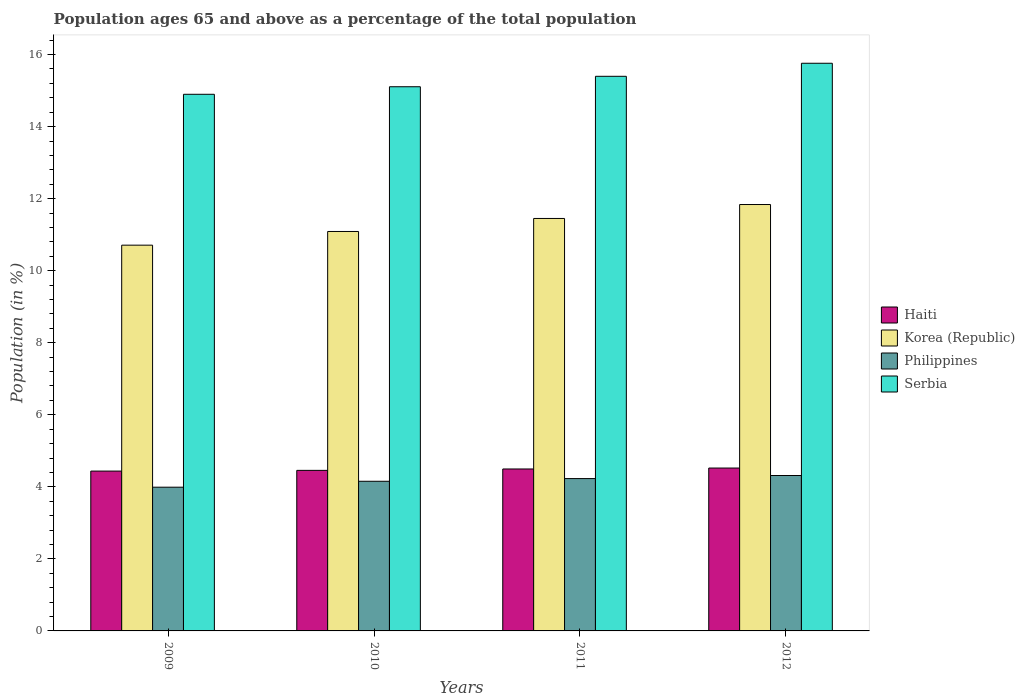How many bars are there on the 1st tick from the left?
Offer a very short reply. 4. How many bars are there on the 4th tick from the right?
Your response must be concise. 4. What is the percentage of the population ages 65 and above in Korea (Republic) in 2011?
Make the answer very short. 11.45. Across all years, what is the maximum percentage of the population ages 65 and above in Korea (Republic)?
Give a very brief answer. 11.84. Across all years, what is the minimum percentage of the population ages 65 and above in Haiti?
Offer a terse response. 4.44. In which year was the percentage of the population ages 65 and above in Philippines minimum?
Your answer should be very brief. 2009. What is the total percentage of the population ages 65 and above in Korea (Republic) in the graph?
Give a very brief answer. 45.08. What is the difference between the percentage of the population ages 65 and above in Korea (Republic) in 2010 and that in 2011?
Offer a terse response. -0.36. What is the difference between the percentage of the population ages 65 and above in Philippines in 2011 and the percentage of the population ages 65 and above in Korea (Republic) in 2010?
Offer a very short reply. -6.86. What is the average percentage of the population ages 65 and above in Korea (Republic) per year?
Your answer should be very brief. 11.27. In the year 2009, what is the difference between the percentage of the population ages 65 and above in Philippines and percentage of the population ages 65 and above in Haiti?
Your answer should be very brief. -0.45. What is the ratio of the percentage of the population ages 65 and above in Korea (Republic) in 2011 to that in 2012?
Offer a very short reply. 0.97. What is the difference between the highest and the second highest percentage of the population ages 65 and above in Philippines?
Provide a short and direct response. 0.09. What is the difference between the highest and the lowest percentage of the population ages 65 and above in Philippines?
Ensure brevity in your answer.  0.32. Is it the case that in every year, the sum of the percentage of the population ages 65 and above in Haiti and percentage of the population ages 65 and above in Korea (Republic) is greater than the sum of percentage of the population ages 65 and above in Serbia and percentage of the population ages 65 and above in Philippines?
Provide a succinct answer. Yes. Is it the case that in every year, the sum of the percentage of the population ages 65 and above in Serbia and percentage of the population ages 65 and above in Haiti is greater than the percentage of the population ages 65 and above in Philippines?
Your answer should be compact. Yes. How many bars are there?
Offer a terse response. 16. Where does the legend appear in the graph?
Ensure brevity in your answer.  Center right. What is the title of the graph?
Offer a very short reply. Population ages 65 and above as a percentage of the total population. What is the Population (in %) in Haiti in 2009?
Make the answer very short. 4.44. What is the Population (in %) of Korea (Republic) in 2009?
Provide a succinct answer. 10.71. What is the Population (in %) of Philippines in 2009?
Give a very brief answer. 3.99. What is the Population (in %) in Serbia in 2009?
Your response must be concise. 14.9. What is the Population (in %) of Haiti in 2010?
Make the answer very short. 4.46. What is the Population (in %) in Korea (Republic) in 2010?
Your response must be concise. 11.09. What is the Population (in %) in Philippines in 2010?
Your answer should be compact. 4.15. What is the Population (in %) of Serbia in 2010?
Offer a terse response. 15.11. What is the Population (in %) in Haiti in 2011?
Make the answer very short. 4.5. What is the Population (in %) of Korea (Republic) in 2011?
Provide a succinct answer. 11.45. What is the Population (in %) of Philippines in 2011?
Provide a short and direct response. 4.23. What is the Population (in %) in Serbia in 2011?
Offer a very short reply. 15.4. What is the Population (in %) in Haiti in 2012?
Make the answer very short. 4.52. What is the Population (in %) in Korea (Republic) in 2012?
Provide a short and direct response. 11.84. What is the Population (in %) of Philippines in 2012?
Offer a terse response. 4.31. What is the Population (in %) of Serbia in 2012?
Your answer should be compact. 15.76. Across all years, what is the maximum Population (in %) in Haiti?
Give a very brief answer. 4.52. Across all years, what is the maximum Population (in %) in Korea (Republic)?
Your response must be concise. 11.84. Across all years, what is the maximum Population (in %) in Philippines?
Keep it short and to the point. 4.31. Across all years, what is the maximum Population (in %) of Serbia?
Keep it short and to the point. 15.76. Across all years, what is the minimum Population (in %) of Haiti?
Your answer should be compact. 4.44. Across all years, what is the minimum Population (in %) in Korea (Republic)?
Make the answer very short. 10.71. Across all years, what is the minimum Population (in %) of Philippines?
Your answer should be very brief. 3.99. Across all years, what is the minimum Population (in %) in Serbia?
Provide a short and direct response. 14.9. What is the total Population (in %) in Haiti in the graph?
Your answer should be compact. 17.91. What is the total Population (in %) in Korea (Republic) in the graph?
Your response must be concise. 45.08. What is the total Population (in %) in Philippines in the graph?
Make the answer very short. 16.69. What is the total Population (in %) of Serbia in the graph?
Your answer should be very brief. 61.16. What is the difference between the Population (in %) in Haiti in 2009 and that in 2010?
Give a very brief answer. -0.02. What is the difference between the Population (in %) of Korea (Republic) in 2009 and that in 2010?
Provide a succinct answer. -0.38. What is the difference between the Population (in %) in Philippines in 2009 and that in 2010?
Offer a very short reply. -0.16. What is the difference between the Population (in %) in Serbia in 2009 and that in 2010?
Your answer should be very brief. -0.21. What is the difference between the Population (in %) in Haiti in 2009 and that in 2011?
Your response must be concise. -0.06. What is the difference between the Population (in %) in Korea (Republic) in 2009 and that in 2011?
Offer a terse response. -0.74. What is the difference between the Population (in %) of Philippines in 2009 and that in 2011?
Offer a very short reply. -0.24. What is the difference between the Population (in %) in Serbia in 2009 and that in 2011?
Provide a short and direct response. -0.5. What is the difference between the Population (in %) in Haiti in 2009 and that in 2012?
Offer a very short reply. -0.08. What is the difference between the Population (in %) in Korea (Republic) in 2009 and that in 2012?
Your response must be concise. -1.13. What is the difference between the Population (in %) in Philippines in 2009 and that in 2012?
Provide a short and direct response. -0.32. What is the difference between the Population (in %) in Serbia in 2009 and that in 2012?
Your response must be concise. -0.86. What is the difference between the Population (in %) in Haiti in 2010 and that in 2011?
Ensure brevity in your answer.  -0.04. What is the difference between the Population (in %) in Korea (Republic) in 2010 and that in 2011?
Provide a succinct answer. -0.36. What is the difference between the Population (in %) of Philippines in 2010 and that in 2011?
Ensure brevity in your answer.  -0.07. What is the difference between the Population (in %) of Serbia in 2010 and that in 2011?
Give a very brief answer. -0.29. What is the difference between the Population (in %) in Haiti in 2010 and that in 2012?
Your response must be concise. -0.06. What is the difference between the Population (in %) in Korea (Republic) in 2010 and that in 2012?
Your answer should be very brief. -0.75. What is the difference between the Population (in %) in Philippines in 2010 and that in 2012?
Provide a succinct answer. -0.16. What is the difference between the Population (in %) in Serbia in 2010 and that in 2012?
Make the answer very short. -0.65. What is the difference between the Population (in %) in Haiti in 2011 and that in 2012?
Offer a very short reply. -0.03. What is the difference between the Population (in %) of Korea (Republic) in 2011 and that in 2012?
Offer a very short reply. -0.39. What is the difference between the Population (in %) of Philippines in 2011 and that in 2012?
Provide a short and direct response. -0.09. What is the difference between the Population (in %) of Serbia in 2011 and that in 2012?
Provide a succinct answer. -0.36. What is the difference between the Population (in %) of Haiti in 2009 and the Population (in %) of Korea (Republic) in 2010?
Keep it short and to the point. -6.65. What is the difference between the Population (in %) in Haiti in 2009 and the Population (in %) in Philippines in 2010?
Ensure brevity in your answer.  0.28. What is the difference between the Population (in %) in Haiti in 2009 and the Population (in %) in Serbia in 2010?
Provide a short and direct response. -10.67. What is the difference between the Population (in %) in Korea (Republic) in 2009 and the Population (in %) in Philippines in 2010?
Offer a terse response. 6.55. What is the difference between the Population (in %) of Korea (Republic) in 2009 and the Population (in %) of Serbia in 2010?
Your response must be concise. -4.4. What is the difference between the Population (in %) of Philippines in 2009 and the Population (in %) of Serbia in 2010?
Offer a terse response. -11.12. What is the difference between the Population (in %) of Haiti in 2009 and the Population (in %) of Korea (Republic) in 2011?
Make the answer very short. -7.01. What is the difference between the Population (in %) of Haiti in 2009 and the Population (in %) of Philippines in 2011?
Make the answer very short. 0.21. What is the difference between the Population (in %) of Haiti in 2009 and the Population (in %) of Serbia in 2011?
Offer a very short reply. -10.96. What is the difference between the Population (in %) in Korea (Republic) in 2009 and the Population (in %) in Philippines in 2011?
Your answer should be very brief. 6.48. What is the difference between the Population (in %) of Korea (Republic) in 2009 and the Population (in %) of Serbia in 2011?
Your response must be concise. -4.69. What is the difference between the Population (in %) of Philippines in 2009 and the Population (in %) of Serbia in 2011?
Make the answer very short. -11.41. What is the difference between the Population (in %) in Haiti in 2009 and the Population (in %) in Philippines in 2012?
Keep it short and to the point. 0.12. What is the difference between the Population (in %) of Haiti in 2009 and the Population (in %) of Serbia in 2012?
Make the answer very short. -11.32. What is the difference between the Population (in %) in Korea (Republic) in 2009 and the Population (in %) in Philippines in 2012?
Provide a short and direct response. 6.39. What is the difference between the Population (in %) in Korea (Republic) in 2009 and the Population (in %) in Serbia in 2012?
Your answer should be very brief. -5.05. What is the difference between the Population (in %) of Philippines in 2009 and the Population (in %) of Serbia in 2012?
Ensure brevity in your answer.  -11.77. What is the difference between the Population (in %) in Haiti in 2010 and the Population (in %) in Korea (Republic) in 2011?
Provide a short and direct response. -6.99. What is the difference between the Population (in %) in Haiti in 2010 and the Population (in %) in Philippines in 2011?
Provide a short and direct response. 0.23. What is the difference between the Population (in %) in Haiti in 2010 and the Population (in %) in Serbia in 2011?
Provide a succinct answer. -10.94. What is the difference between the Population (in %) of Korea (Republic) in 2010 and the Population (in %) of Philippines in 2011?
Provide a succinct answer. 6.86. What is the difference between the Population (in %) in Korea (Republic) in 2010 and the Population (in %) in Serbia in 2011?
Provide a short and direct response. -4.31. What is the difference between the Population (in %) of Philippines in 2010 and the Population (in %) of Serbia in 2011?
Offer a very short reply. -11.24. What is the difference between the Population (in %) of Haiti in 2010 and the Population (in %) of Korea (Republic) in 2012?
Offer a terse response. -7.38. What is the difference between the Population (in %) of Haiti in 2010 and the Population (in %) of Philippines in 2012?
Provide a succinct answer. 0.14. What is the difference between the Population (in %) in Haiti in 2010 and the Population (in %) in Serbia in 2012?
Offer a very short reply. -11.3. What is the difference between the Population (in %) of Korea (Republic) in 2010 and the Population (in %) of Philippines in 2012?
Offer a very short reply. 6.77. What is the difference between the Population (in %) in Korea (Republic) in 2010 and the Population (in %) in Serbia in 2012?
Provide a short and direct response. -4.67. What is the difference between the Population (in %) of Philippines in 2010 and the Population (in %) of Serbia in 2012?
Give a very brief answer. -11.6. What is the difference between the Population (in %) in Haiti in 2011 and the Population (in %) in Korea (Republic) in 2012?
Ensure brevity in your answer.  -7.34. What is the difference between the Population (in %) in Haiti in 2011 and the Population (in %) in Philippines in 2012?
Your answer should be compact. 0.18. What is the difference between the Population (in %) in Haiti in 2011 and the Population (in %) in Serbia in 2012?
Provide a short and direct response. -11.26. What is the difference between the Population (in %) of Korea (Republic) in 2011 and the Population (in %) of Philippines in 2012?
Ensure brevity in your answer.  7.14. What is the difference between the Population (in %) in Korea (Republic) in 2011 and the Population (in %) in Serbia in 2012?
Your response must be concise. -4.31. What is the difference between the Population (in %) of Philippines in 2011 and the Population (in %) of Serbia in 2012?
Offer a terse response. -11.53. What is the average Population (in %) of Haiti per year?
Give a very brief answer. 4.48. What is the average Population (in %) in Korea (Republic) per year?
Your response must be concise. 11.27. What is the average Population (in %) of Philippines per year?
Your answer should be very brief. 4.17. What is the average Population (in %) in Serbia per year?
Give a very brief answer. 15.29. In the year 2009, what is the difference between the Population (in %) of Haiti and Population (in %) of Korea (Republic)?
Give a very brief answer. -6.27. In the year 2009, what is the difference between the Population (in %) in Haiti and Population (in %) in Philippines?
Make the answer very short. 0.45. In the year 2009, what is the difference between the Population (in %) in Haiti and Population (in %) in Serbia?
Provide a succinct answer. -10.46. In the year 2009, what is the difference between the Population (in %) in Korea (Republic) and Population (in %) in Philippines?
Ensure brevity in your answer.  6.72. In the year 2009, what is the difference between the Population (in %) of Korea (Republic) and Population (in %) of Serbia?
Offer a terse response. -4.19. In the year 2009, what is the difference between the Population (in %) of Philippines and Population (in %) of Serbia?
Offer a very short reply. -10.91. In the year 2010, what is the difference between the Population (in %) in Haiti and Population (in %) in Korea (Republic)?
Make the answer very short. -6.63. In the year 2010, what is the difference between the Population (in %) of Haiti and Population (in %) of Philippines?
Offer a terse response. 0.3. In the year 2010, what is the difference between the Population (in %) of Haiti and Population (in %) of Serbia?
Your answer should be very brief. -10.65. In the year 2010, what is the difference between the Population (in %) of Korea (Republic) and Population (in %) of Philippines?
Your answer should be very brief. 6.93. In the year 2010, what is the difference between the Population (in %) in Korea (Republic) and Population (in %) in Serbia?
Your answer should be very brief. -4.02. In the year 2010, what is the difference between the Population (in %) of Philippines and Population (in %) of Serbia?
Your response must be concise. -10.95. In the year 2011, what is the difference between the Population (in %) in Haiti and Population (in %) in Korea (Republic)?
Give a very brief answer. -6.95. In the year 2011, what is the difference between the Population (in %) in Haiti and Population (in %) in Philippines?
Give a very brief answer. 0.27. In the year 2011, what is the difference between the Population (in %) in Haiti and Population (in %) in Serbia?
Provide a short and direct response. -10.9. In the year 2011, what is the difference between the Population (in %) in Korea (Republic) and Population (in %) in Philippines?
Offer a very short reply. 7.22. In the year 2011, what is the difference between the Population (in %) of Korea (Republic) and Population (in %) of Serbia?
Give a very brief answer. -3.95. In the year 2011, what is the difference between the Population (in %) of Philippines and Population (in %) of Serbia?
Keep it short and to the point. -11.17. In the year 2012, what is the difference between the Population (in %) of Haiti and Population (in %) of Korea (Republic)?
Your answer should be compact. -7.32. In the year 2012, what is the difference between the Population (in %) in Haiti and Population (in %) in Philippines?
Provide a short and direct response. 0.21. In the year 2012, what is the difference between the Population (in %) in Haiti and Population (in %) in Serbia?
Provide a short and direct response. -11.24. In the year 2012, what is the difference between the Population (in %) in Korea (Republic) and Population (in %) in Philippines?
Provide a succinct answer. 7.52. In the year 2012, what is the difference between the Population (in %) of Korea (Republic) and Population (in %) of Serbia?
Offer a very short reply. -3.92. In the year 2012, what is the difference between the Population (in %) of Philippines and Population (in %) of Serbia?
Your answer should be very brief. -11.44. What is the ratio of the Population (in %) of Haiti in 2009 to that in 2010?
Ensure brevity in your answer.  1. What is the ratio of the Population (in %) of Korea (Republic) in 2009 to that in 2010?
Provide a short and direct response. 0.97. What is the ratio of the Population (in %) in Philippines in 2009 to that in 2010?
Your answer should be compact. 0.96. What is the ratio of the Population (in %) in Serbia in 2009 to that in 2010?
Make the answer very short. 0.99. What is the ratio of the Population (in %) in Korea (Republic) in 2009 to that in 2011?
Ensure brevity in your answer.  0.94. What is the ratio of the Population (in %) in Philippines in 2009 to that in 2011?
Keep it short and to the point. 0.94. What is the ratio of the Population (in %) of Serbia in 2009 to that in 2011?
Give a very brief answer. 0.97. What is the ratio of the Population (in %) in Haiti in 2009 to that in 2012?
Keep it short and to the point. 0.98. What is the ratio of the Population (in %) of Korea (Republic) in 2009 to that in 2012?
Provide a short and direct response. 0.9. What is the ratio of the Population (in %) in Philippines in 2009 to that in 2012?
Provide a short and direct response. 0.92. What is the ratio of the Population (in %) in Serbia in 2009 to that in 2012?
Keep it short and to the point. 0.95. What is the ratio of the Population (in %) in Haiti in 2010 to that in 2011?
Keep it short and to the point. 0.99. What is the ratio of the Population (in %) in Korea (Republic) in 2010 to that in 2011?
Keep it short and to the point. 0.97. What is the ratio of the Population (in %) of Philippines in 2010 to that in 2011?
Provide a short and direct response. 0.98. What is the ratio of the Population (in %) in Serbia in 2010 to that in 2011?
Provide a succinct answer. 0.98. What is the ratio of the Population (in %) in Haiti in 2010 to that in 2012?
Your answer should be very brief. 0.99. What is the ratio of the Population (in %) of Korea (Republic) in 2010 to that in 2012?
Your answer should be compact. 0.94. What is the ratio of the Population (in %) in Philippines in 2010 to that in 2012?
Provide a short and direct response. 0.96. What is the ratio of the Population (in %) of Serbia in 2010 to that in 2012?
Offer a very short reply. 0.96. What is the ratio of the Population (in %) of Korea (Republic) in 2011 to that in 2012?
Your response must be concise. 0.97. What is the ratio of the Population (in %) of Philippines in 2011 to that in 2012?
Provide a short and direct response. 0.98. What is the ratio of the Population (in %) in Serbia in 2011 to that in 2012?
Keep it short and to the point. 0.98. What is the difference between the highest and the second highest Population (in %) of Haiti?
Provide a short and direct response. 0.03. What is the difference between the highest and the second highest Population (in %) in Korea (Republic)?
Offer a terse response. 0.39. What is the difference between the highest and the second highest Population (in %) of Philippines?
Offer a terse response. 0.09. What is the difference between the highest and the second highest Population (in %) of Serbia?
Make the answer very short. 0.36. What is the difference between the highest and the lowest Population (in %) of Haiti?
Make the answer very short. 0.08. What is the difference between the highest and the lowest Population (in %) of Korea (Republic)?
Offer a very short reply. 1.13. What is the difference between the highest and the lowest Population (in %) in Philippines?
Keep it short and to the point. 0.32. What is the difference between the highest and the lowest Population (in %) of Serbia?
Offer a very short reply. 0.86. 